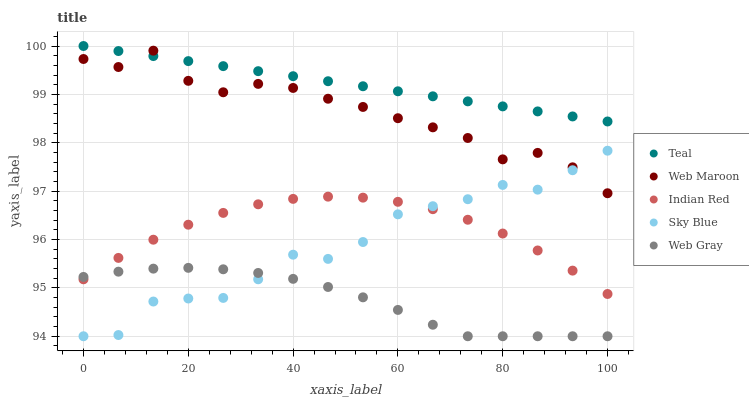Does Web Gray have the minimum area under the curve?
Answer yes or no. Yes. Does Teal have the maximum area under the curve?
Answer yes or no. Yes. Does Web Maroon have the minimum area under the curve?
Answer yes or no. No. Does Web Maroon have the maximum area under the curve?
Answer yes or no. No. Is Teal the smoothest?
Answer yes or no. Yes. Is Sky Blue the roughest?
Answer yes or no. Yes. Is Web Gray the smoothest?
Answer yes or no. No. Is Web Gray the roughest?
Answer yes or no. No. Does Sky Blue have the lowest value?
Answer yes or no. Yes. Does Web Maroon have the lowest value?
Answer yes or no. No. Does Teal have the highest value?
Answer yes or no. Yes. Does Web Maroon have the highest value?
Answer yes or no. No. Is Web Gray less than Web Maroon?
Answer yes or no. Yes. Is Web Maroon greater than Web Gray?
Answer yes or no. Yes. Does Sky Blue intersect Indian Red?
Answer yes or no. Yes. Is Sky Blue less than Indian Red?
Answer yes or no. No. Is Sky Blue greater than Indian Red?
Answer yes or no. No. Does Web Gray intersect Web Maroon?
Answer yes or no. No. 